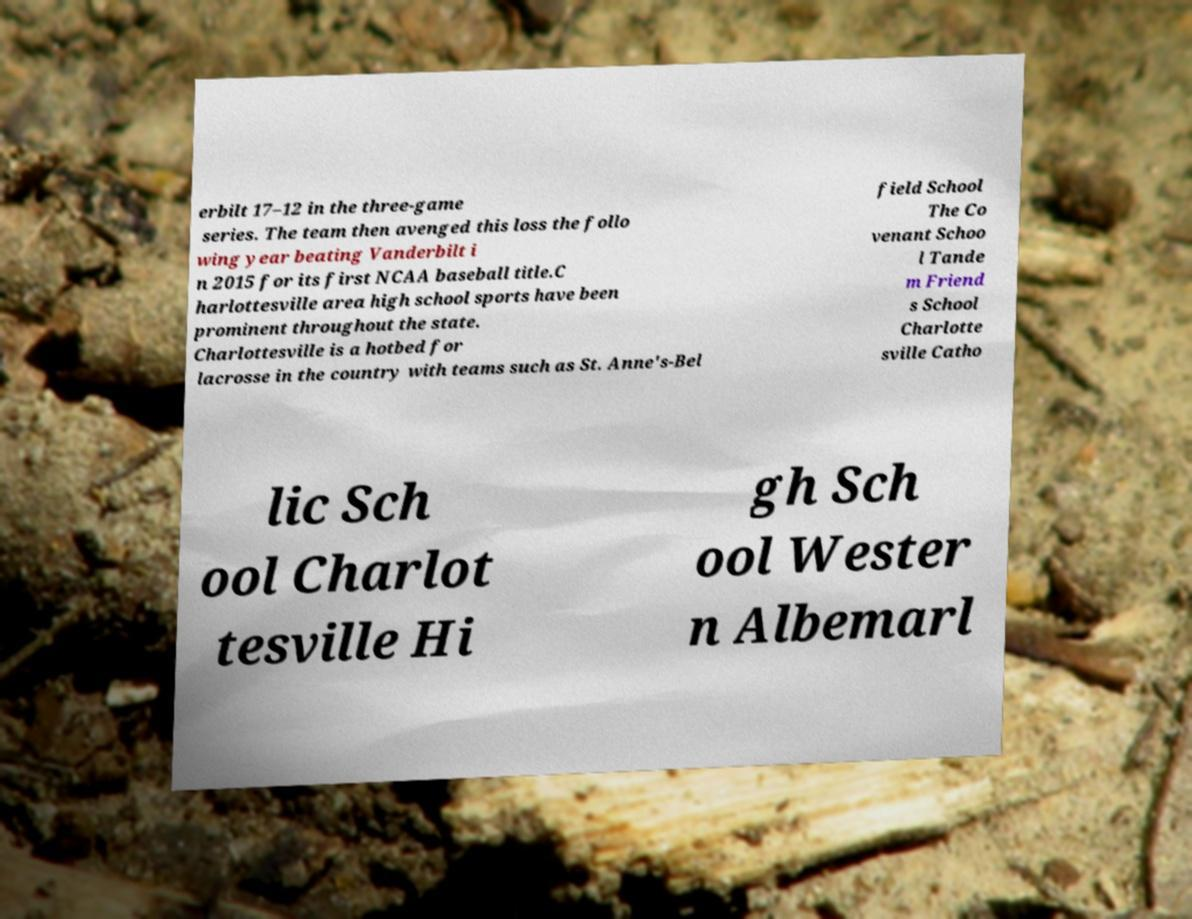Could you extract and type out the text from this image? erbilt 17–12 in the three-game series. The team then avenged this loss the follo wing year beating Vanderbilt i n 2015 for its first NCAA baseball title.C harlottesville area high school sports have been prominent throughout the state. Charlottesville is a hotbed for lacrosse in the country with teams such as St. Anne's-Bel field School The Co venant Schoo l Tande m Friend s School Charlotte sville Catho lic Sch ool Charlot tesville Hi gh Sch ool Wester n Albemarl 